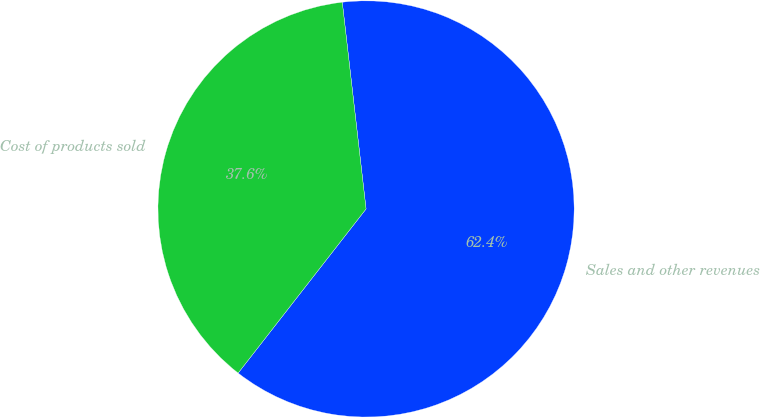Convert chart to OTSL. <chart><loc_0><loc_0><loc_500><loc_500><pie_chart><fcel>Sales and other revenues<fcel>Cost of products sold<nl><fcel>62.36%<fcel>37.64%<nl></chart> 